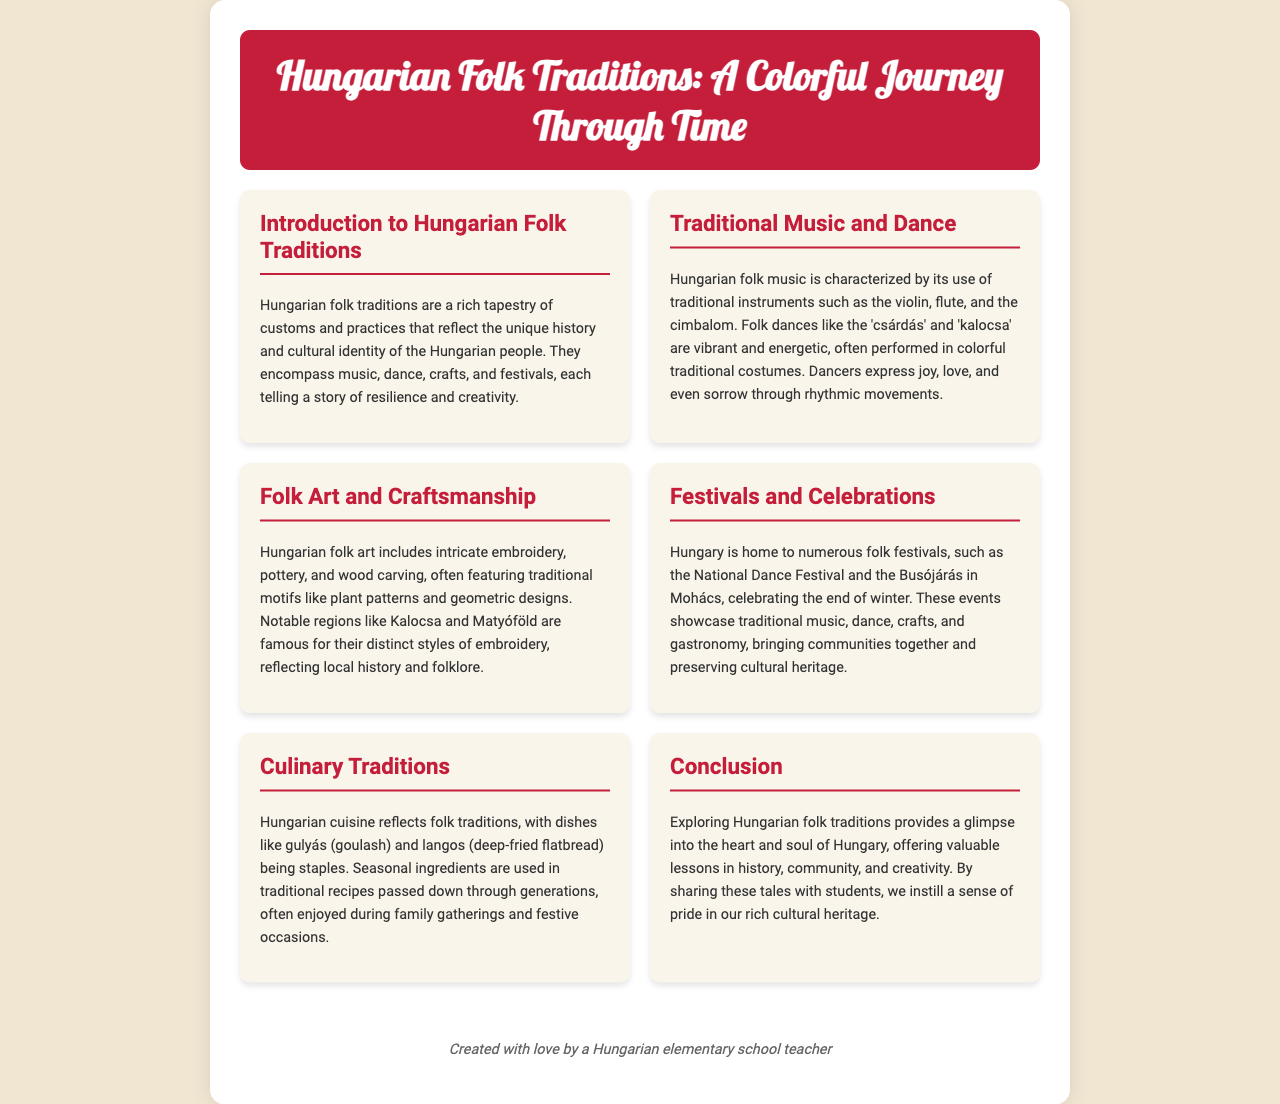what is the title of the document? The title is prominently featured at the top of the document, highlighting the main subject.
Answer: Hungarian Folk Traditions: A Colorful Journey Through Time what are two traditional instruments used in Hungarian folk music? The document lists traditional instruments used in folk music, emphasizing their importance in performances.
Answer: violin, cimbalom name a famous folk festival in Hungary. The document mentions specific festivals that celebrate folk traditions in Hungary, focusing on community involvement.
Answer: Busójárás which dish is mentioned as a staple of Hungarian cuisine? The document elaborates on dishes that reflect culinary traditions, showcasing their cultural significance.
Answer: gulyás what type of embroidery is famous in Matyóföld? The document notes specific regional styles of embroidery, highlighting their uniqueness and cultural ties.
Answer: distinct styles how do folk dances express emotions, according to the document? The document explains the purpose and expressiveness of folk dances within the cultural context.
Answer: joy, love, and even sorrow what is emphasized as part of community events in the festivals? The document describes elements that are key to folk festivals, showcasing their role in preserving culture.
Answer: traditional music and dance what is the overall theme of the document? The document outlines the general focus of its contents, reflecting its educational purpose.
Answer: folk traditions 